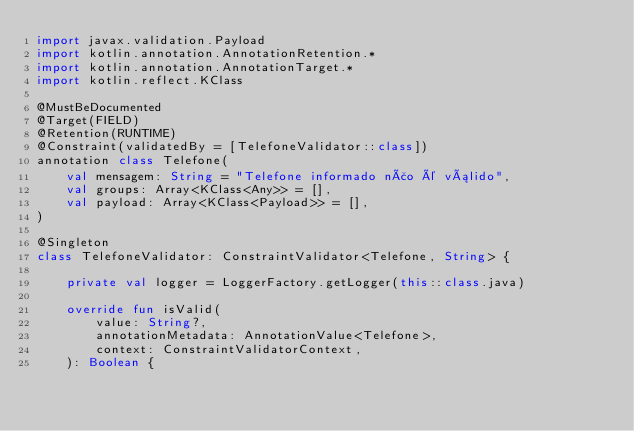<code> <loc_0><loc_0><loc_500><loc_500><_Kotlin_>import javax.validation.Payload
import kotlin.annotation.AnnotationRetention.*
import kotlin.annotation.AnnotationTarget.*
import kotlin.reflect.KClass

@MustBeDocumented
@Target(FIELD)
@Retention(RUNTIME)
@Constraint(validatedBy = [TelefoneValidator::class])
annotation class Telefone(
    val mensagem: String = "Telefone informado não é válido",
    val groups: Array<KClass<Any>> = [],
    val payload: Array<KClass<Payload>> = [],
)

@Singleton
class TelefoneValidator: ConstraintValidator<Telefone, String> {

    private val logger = LoggerFactory.getLogger(this::class.java)

    override fun isValid(
        value: String?,
        annotationMetadata: AnnotationValue<Telefone>,
        context: ConstraintValidatorContext,
    ): Boolean {</code> 